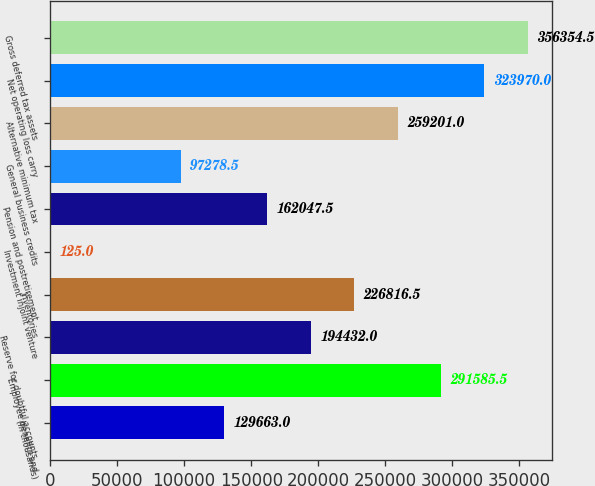Convert chart to OTSL. <chart><loc_0><loc_0><loc_500><loc_500><bar_chart><fcel>(In thousands)<fcel>Employee benefits and<fcel>Reserve for doubtful accounts<fcel>Inventories<fcel>Investment injoint venture<fcel>Pension and postretirement<fcel>General business credits<fcel>Alternative minimum tax<fcel>Net operating loss carry<fcel>Gross deferred tax assets<nl><fcel>129663<fcel>291586<fcel>194432<fcel>226816<fcel>125<fcel>162048<fcel>97278.5<fcel>259201<fcel>323970<fcel>356354<nl></chart> 